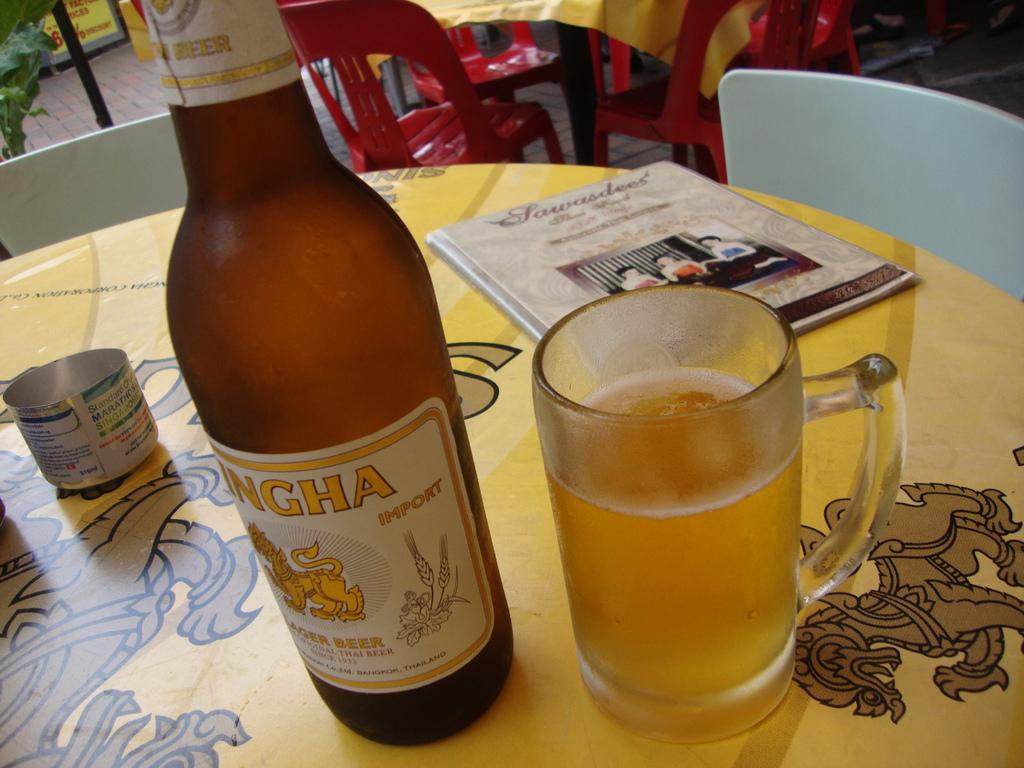Provide a one-sentence caption for the provided image. Singh beer bottle next to a glass of beer on top of a table. 